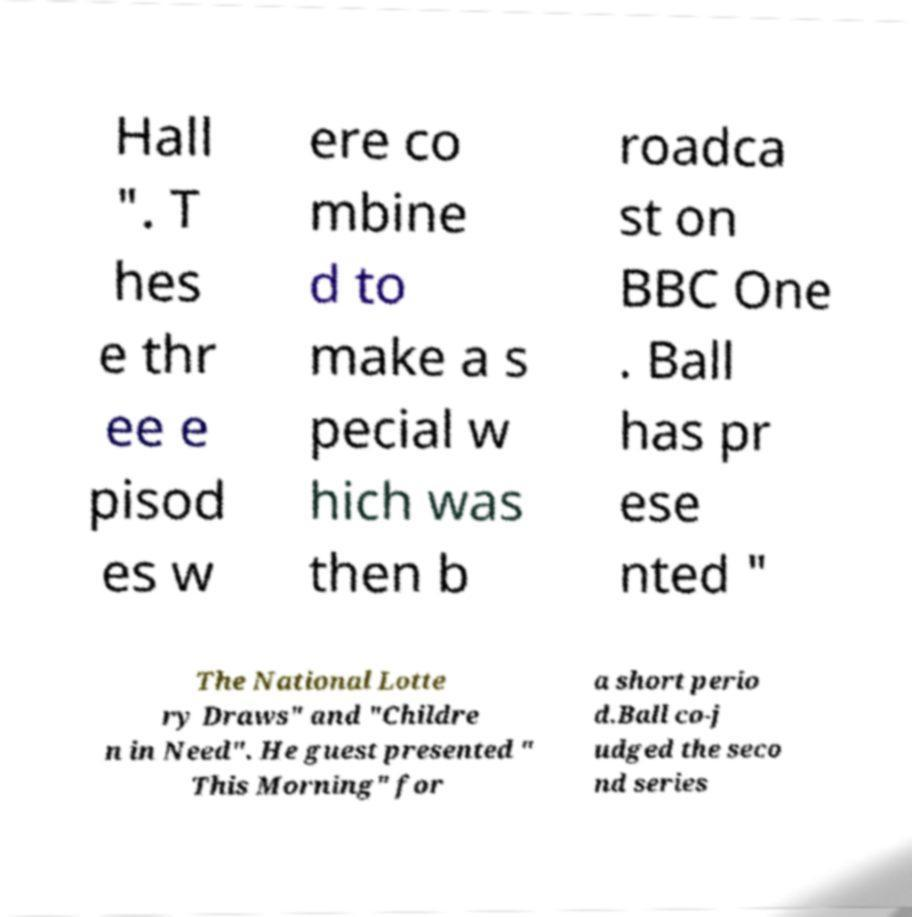Please identify and transcribe the text found in this image. Hall ". T hes e thr ee e pisod es w ere co mbine d to make a s pecial w hich was then b roadca st on BBC One . Ball has pr ese nted " The National Lotte ry Draws" and "Childre n in Need". He guest presented " This Morning" for a short perio d.Ball co-j udged the seco nd series 